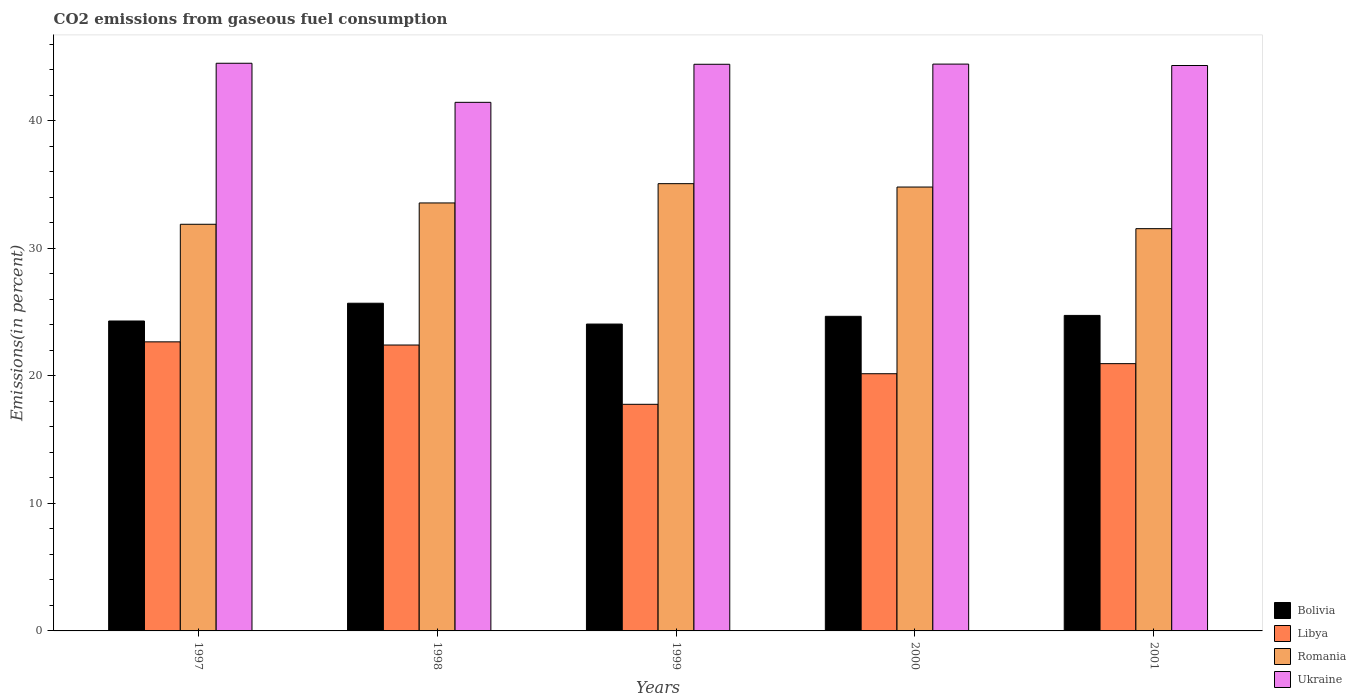How many groups of bars are there?
Make the answer very short. 5. Are the number of bars on each tick of the X-axis equal?
Give a very brief answer. Yes. How many bars are there on the 3rd tick from the left?
Your response must be concise. 4. How many bars are there on the 3rd tick from the right?
Your answer should be very brief. 4. In how many cases, is the number of bars for a given year not equal to the number of legend labels?
Offer a very short reply. 0. What is the total CO2 emitted in Bolivia in 1998?
Keep it short and to the point. 25.7. Across all years, what is the maximum total CO2 emitted in Bolivia?
Offer a very short reply. 25.7. Across all years, what is the minimum total CO2 emitted in Romania?
Your answer should be very brief. 31.55. In which year was the total CO2 emitted in Romania maximum?
Your response must be concise. 1999. In which year was the total CO2 emitted in Libya minimum?
Your answer should be compact. 1999. What is the total total CO2 emitted in Libya in the graph?
Your answer should be compact. 104.02. What is the difference between the total CO2 emitted in Bolivia in 1998 and that in 1999?
Provide a succinct answer. 1.63. What is the difference between the total CO2 emitted in Ukraine in 1998 and the total CO2 emitted in Libya in 1997?
Offer a very short reply. 18.79. What is the average total CO2 emitted in Romania per year?
Your answer should be very brief. 33.38. In the year 2000, what is the difference between the total CO2 emitted in Romania and total CO2 emitted in Ukraine?
Provide a short and direct response. -9.64. In how many years, is the total CO2 emitted in Bolivia greater than 26 %?
Offer a terse response. 0. What is the ratio of the total CO2 emitted in Bolivia in 1999 to that in 2001?
Your answer should be compact. 0.97. Is the total CO2 emitted in Libya in 1998 less than that in 1999?
Give a very brief answer. No. Is the difference between the total CO2 emitted in Romania in 1997 and 1999 greater than the difference between the total CO2 emitted in Ukraine in 1997 and 1999?
Provide a short and direct response. No. What is the difference between the highest and the second highest total CO2 emitted in Bolivia?
Offer a terse response. 0.96. What is the difference between the highest and the lowest total CO2 emitted in Ukraine?
Offer a very short reply. 3.07. Is the sum of the total CO2 emitted in Libya in 1998 and 2001 greater than the maximum total CO2 emitted in Bolivia across all years?
Make the answer very short. Yes. Is it the case that in every year, the sum of the total CO2 emitted in Libya and total CO2 emitted in Romania is greater than the sum of total CO2 emitted in Bolivia and total CO2 emitted in Ukraine?
Make the answer very short. No. What does the 2nd bar from the left in 1998 represents?
Your response must be concise. Libya. What does the 2nd bar from the right in 1998 represents?
Make the answer very short. Romania. Is it the case that in every year, the sum of the total CO2 emitted in Romania and total CO2 emitted in Bolivia is greater than the total CO2 emitted in Libya?
Offer a very short reply. Yes. How many years are there in the graph?
Provide a succinct answer. 5. What is the difference between two consecutive major ticks on the Y-axis?
Offer a terse response. 10. Does the graph contain grids?
Provide a succinct answer. No. Where does the legend appear in the graph?
Offer a very short reply. Bottom right. What is the title of the graph?
Your answer should be compact. CO2 emissions from gaseous fuel consumption. Does "Cayman Islands" appear as one of the legend labels in the graph?
Your answer should be very brief. No. What is the label or title of the X-axis?
Keep it short and to the point. Years. What is the label or title of the Y-axis?
Offer a very short reply. Emissions(in percent). What is the Emissions(in percent) in Bolivia in 1997?
Provide a short and direct response. 24.31. What is the Emissions(in percent) of Libya in 1997?
Your answer should be compact. 22.67. What is the Emissions(in percent) of Romania in 1997?
Your answer should be very brief. 31.9. What is the Emissions(in percent) of Ukraine in 1997?
Your answer should be very brief. 44.53. What is the Emissions(in percent) in Bolivia in 1998?
Keep it short and to the point. 25.7. What is the Emissions(in percent) in Libya in 1998?
Provide a short and direct response. 22.43. What is the Emissions(in percent) of Romania in 1998?
Ensure brevity in your answer.  33.57. What is the Emissions(in percent) of Ukraine in 1998?
Provide a succinct answer. 41.46. What is the Emissions(in percent) in Bolivia in 1999?
Provide a short and direct response. 24.07. What is the Emissions(in percent) in Libya in 1999?
Ensure brevity in your answer.  17.78. What is the Emissions(in percent) in Romania in 1999?
Ensure brevity in your answer.  35.08. What is the Emissions(in percent) of Ukraine in 1999?
Keep it short and to the point. 44.45. What is the Emissions(in percent) of Bolivia in 2000?
Keep it short and to the point. 24.68. What is the Emissions(in percent) of Libya in 2000?
Offer a terse response. 20.17. What is the Emissions(in percent) in Romania in 2000?
Make the answer very short. 34.82. What is the Emissions(in percent) of Ukraine in 2000?
Offer a very short reply. 44.46. What is the Emissions(in percent) in Bolivia in 2001?
Your response must be concise. 24.75. What is the Emissions(in percent) of Libya in 2001?
Your answer should be very brief. 20.97. What is the Emissions(in percent) in Romania in 2001?
Offer a very short reply. 31.55. What is the Emissions(in percent) in Ukraine in 2001?
Ensure brevity in your answer.  44.35. Across all years, what is the maximum Emissions(in percent) of Bolivia?
Give a very brief answer. 25.7. Across all years, what is the maximum Emissions(in percent) in Libya?
Ensure brevity in your answer.  22.67. Across all years, what is the maximum Emissions(in percent) of Romania?
Make the answer very short. 35.08. Across all years, what is the maximum Emissions(in percent) in Ukraine?
Provide a short and direct response. 44.53. Across all years, what is the minimum Emissions(in percent) in Bolivia?
Your answer should be very brief. 24.07. Across all years, what is the minimum Emissions(in percent) of Libya?
Ensure brevity in your answer.  17.78. Across all years, what is the minimum Emissions(in percent) in Romania?
Keep it short and to the point. 31.55. Across all years, what is the minimum Emissions(in percent) in Ukraine?
Offer a very short reply. 41.46. What is the total Emissions(in percent) in Bolivia in the graph?
Your answer should be very brief. 123.51. What is the total Emissions(in percent) of Libya in the graph?
Make the answer very short. 104.02. What is the total Emissions(in percent) in Romania in the graph?
Provide a succinct answer. 166.92. What is the total Emissions(in percent) in Ukraine in the graph?
Keep it short and to the point. 219.25. What is the difference between the Emissions(in percent) of Bolivia in 1997 and that in 1998?
Give a very brief answer. -1.39. What is the difference between the Emissions(in percent) of Libya in 1997 and that in 1998?
Offer a very short reply. 0.25. What is the difference between the Emissions(in percent) in Romania in 1997 and that in 1998?
Offer a terse response. -1.67. What is the difference between the Emissions(in percent) in Ukraine in 1997 and that in 1998?
Offer a terse response. 3.07. What is the difference between the Emissions(in percent) of Bolivia in 1997 and that in 1999?
Ensure brevity in your answer.  0.24. What is the difference between the Emissions(in percent) in Libya in 1997 and that in 1999?
Offer a terse response. 4.9. What is the difference between the Emissions(in percent) of Romania in 1997 and that in 1999?
Offer a very short reply. -3.19. What is the difference between the Emissions(in percent) in Ukraine in 1997 and that in 1999?
Keep it short and to the point. 0.08. What is the difference between the Emissions(in percent) in Bolivia in 1997 and that in 2000?
Your answer should be very brief. -0.37. What is the difference between the Emissions(in percent) of Libya in 1997 and that in 2000?
Offer a very short reply. 2.5. What is the difference between the Emissions(in percent) in Romania in 1997 and that in 2000?
Make the answer very short. -2.92. What is the difference between the Emissions(in percent) in Ukraine in 1997 and that in 2000?
Your answer should be very brief. 0.07. What is the difference between the Emissions(in percent) in Bolivia in 1997 and that in 2001?
Ensure brevity in your answer.  -0.44. What is the difference between the Emissions(in percent) in Libya in 1997 and that in 2001?
Make the answer very short. 1.71. What is the difference between the Emissions(in percent) of Romania in 1997 and that in 2001?
Provide a succinct answer. 0.34. What is the difference between the Emissions(in percent) of Ukraine in 1997 and that in 2001?
Keep it short and to the point. 0.18. What is the difference between the Emissions(in percent) in Bolivia in 1998 and that in 1999?
Provide a short and direct response. 1.63. What is the difference between the Emissions(in percent) in Libya in 1998 and that in 1999?
Keep it short and to the point. 4.65. What is the difference between the Emissions(in percent) in Romania in 1998 and that in 1999?
Make the answer very short. -1.51. What is the difference between the Emissions(in percent) of Ukraine in 1998 and that in 1999?
Offer a very short reply. -2.99. What is the difference between the Emissions(in percent) of Libya in 1998 and that in 2000?
Ensure brevity in your answer.  2.25. What is the difference between the Emissions(in percent) of Romania in 1998 and that in 2000?
Give a very brief answer. -1.25. What is the difference between the Emissions(in percent) in Ukraine in 1998 and that in 2000?
Give a very brief answer. -3. What is the difference between the Emissions(in percent) in Bolivia in 1998 and that in 2001?
Make the answer very short. 0.96. What is the difference between the Emissions(in percent) of Libya in 1998 and that in 2001?
Offer a very short reply. 1.46. What is the difference between the Emissions(in percent) in Romania in 1998 and that in 2001?
Offer a very short reply. 2.02. What is the difference between the Emissions(in percent) in Ukraine in 1998 and that in 2001?
Ensure brevity in your answer.  -2.89. What is the difference between the Emissions(in percent) in Bolivia in 1999 and that in 2000?
Offer a very short reply. -0.61. What is the difference between the Emissions(in percent) in Libya in 1999 and that in 2000?
Your response must be concise. -2.4. What is the difference between the Emissions(in percent) of Romania in 1999 and that in 2000?
Your response must be concise. 0.26. What is the difference between the Emissions(in percent) of Ukraine in 1999 and that in 2000?
Keep it short and to the point. -0.01. What is the difference between the Emissions(in percent) of Bolivia in 1999 and that in 2001?
Offer a terse response. -0.68. What is the difference between the Emissions(in percent) of Libya in 1999 and that in 2001?
Your answer should be very brief. -3.19. What is the difference between the Emissions(in percent) of Romania in 1999 and that in 2001?
Offer a very short reply. 3.53. What is the difference between the Emissions(in percent) of Ukraine in 1999 and that in 2001?
Keep it short and to the point. 0.1. What is the difference between the Emissions(in percent) of Bolivia in 2000 and that in 2001?
Your answer should be compact. -0.07. What is the difference between the Emissions(in percent) of Libya in 2000 and that in 2001?
Your answer should be compact. -0.79. What is the difference between the Emissions(in percent) in Romania in 2000 and that in 2001?
Make the answer very short. 3.27. What is the difference between the Emissions(in percent) in Ukraine in 2000 and that in 2001?
Give a very brief answer. 0.11. What is the difference between the Emissions(in percent) of Bolivia in 1997 and the Emissions(in percent) of Libya in 1998?
Provide a short and direct response. 1.88. What is the difference between the Emissions(in percent) in Bolivia in 1997 and the Emissions(in percent) in Romania in 1998?
Provide a short and direct response. -9.26. What is the difference between the Emissions(in percent) of Bolivia in 1997 and the Emissions(in percent) of Ukraine in 1998?
Offer a very short reply. -17.15. What is the difference between the Emissions(in percent) of Libya in 1997 and the Emissions(in percent) of Romania in 1998?
Ensure brevity in your answer.  -10.9. What is the difference between the Emissions(in percent) of Libya in 1997 and the Emissions(in percent) of Ukraine in 1998?
Make the answer very short. -18.79. What is the difference between the Emissions(in percent) of Romania in 1997 and the Emissions(in percent) of Ukraine in 1998?
Your response must be concise. -9.56. What is the difference between the Emissions(in percent) of Bolivia in 1997 and the Emissions(in percent) of Libya in 1999?
Your response must be concise. 6.53. What is the difference between the Emissions(in percent) of Bolivia in 1997 and the Emissions(in percent) of Romania in 1999?
Offer a very short reply. -10.77. What is the difference between the Emissions(in percent) of Bolivia in 1997 and the Emissions(in percent) of Ukraine in 1999?
Provide a succinct answer. -20.14. What is the difference between the Emissions(in percent) in Libya in 1997 and the Emissions(in percent) in Romania in 1999?
Your response must be concise. -12.41. What is the difference between the Emissions(in percent) of Libya in 1997 and the Emissions(in percent) of Ukraine in 1999?
Offer a very short reply. -21.77. What is the difference between the Emissions(in percent) in Romania in 1997 and the Emissions(in percent) in Ukraine in 1999?
Make the answer very short. -12.55. What is the difference between the Emissions(in percent) in Bolivia in 1997 and the Emissions(in percent) in Libya in 2000?
Provide a short and direct response. 4.14. What is the difference between the Emissions(in percent) in Bolivia in 1997 and the Emissions(in percent) in Romania in 2000?
Make the answer very short. -10.51. What is the difference between the Emissions(in percent) in Bolivia in 1997 and the Emissions(in percent) in Ukraine in 2000?
Make the answer very short. -20.15. What is the difference between the Emissions(in percent) of Libya in 1997 and the Emissions(in percent) of Romania in 2000?
Your answer should be compact. -12.14. What is the difference between the Emissions(in percent) of Libya in 1997 and the Emissions(in percent) of Ukraine in 2000?
Keep it short and to the point. -21.79. What is the difference between the Emissions(in percent) in Romania in 1997 and the Emissions(in percent) in Ukraine in 2000?
Give a very brief answer. -12.56. What is the difference between the Emissions(in percent) of Bolivia in 1997 and the Emissions(in percent) of Libya in 2001?
Keep it short and to the point. 3.34. What is the difference between the Emissions(in percent) in Bolivia in 1997 and the Emissions(in percent) in Romania in 2001?
Your answer should be very brief. -7.24. What is the difference between the Emissions(in percent) in Bolivia in 1997 and the Emissions(in percent) in Ukraine in 2001?
Ensure brevity in your answer.  -20.04. What is the difference between the Emissions(in percent) of Libya in 1997 and the Emissions(in percent) of Romania in 2001?
Give a very brief answer. -8.88. What is the difference between the Emissions(in percent) of Libya in 1997 and the Emissions(in percent) of Ukraine in 2001?
Offer a very short reply. -21.68. What is the difference between the Emissions(in percent) of Romania in 1997 and the Emissions(in percent) of Ukraine in 2001?
Provide a short and direct response. -12.45. What is the difference between the Emissions(in percent) of Bolivia in 1998 and the Emissions(in percent) of Libya in 1999?
Your answer should be very brief. 7.93. What is the difference between the Emissions(in percent) of Bolivia in 1998 and the Emissions(in percent) of Romania in 1999?
Your answer should be compact. -9.38. What is the difference between the Emissions(in percent) in Bolivia in 1998 and the Emissions(in percent) in Ukraine in 1999?
Offer a very short reply. -18.74. What is the difference between the Emissions(in percent) of Libya in 1998 and the Emissions(in percent) of Romania in 1999?
Make the answer very short. -12.66. What is the difference between the Emissions(in percent) of Libya in 1998 and the Emissions(in percent) of Ukraine in 1999?
Ensure brevity in your answer.  -22.02. What is the difference between the Emissions(in percent) in Romania in 1998 and the Emissions(in percent) in Ukraine in 1999?
Your response must be concise. -10.88. What is the difference between the Emissions(in percent) in Bolivia in 1998 and the Emissions(in percent) in Libya in 2000?
Offer a terse response. 5.53. What is the difference between the Emissions(in percent) of Bolivia in 1998 and the Emissions(in percent) of Romania in 2000?
Provide a succinct answer. -9.11. What is the difference between the Emissions(in percent) in Bolivia in 1998 and the Emissions(in percent) in Ukraine in 2000?
Your answer should be compact. -18.76. What is the difference between the Emissions(in percent) of Libya in 1998 and the Emissions(in percent) of Romania in 2000?
Your response must be concise. -12.39. What is the difference between the Emissions(in percent) in Libya in 1998 and the Emissions(in percent) in Ukraine in 2000?
Give a very brief answer. -22.03. What is the difference between the Emissions(in percent) of Romania in 1998 and the Emissions(in percent) of Ukraine in 2000?
Your answer should be compact. -10.89. What is the difference between the Emissions(in percent) of Bolivia in 1998 and the Emissions(in percent) of Libya in 2001?
Your answer should be compact. 4.74. What is the difference between the Emissions(in percent) in Bolivia in 1998 and the Emissions(in percent) in Romania in 2001?
Make the answer very short. -5.85. What is the difference between the Emissions(in percent) in Bolivia in 1998 and the Emissions(in percent) in Ukraine in 2001?
Offer a very short reply. -18.65. What is the difference between the Emissions(in percent) in Libya in 1998 and the Emissions(in percent) in Romania in 2001?
Offer a terse response. -9.13. What is the difference between the Emissions(in percent) of Libya in 1998 and the Emissions(in percent) of Ukraine in 2001?
Offer a terse response. -21.92. What is the difference between the Emissions(in percent) in Romania in 1998 and the Emissions(in percent) in Ukraine in 2001?
Provide a succinct answer. -10.78. What is the difference between the Emissions(in percent) in Bolivia in 1999 and the Emissions(in percent) in Libya in 2000?
Make the answer very short. 3.9. What is the difference between the Emissions(in percent) in Bolivia in 1999 and the Emissions(in percent) in Romania in 2000?
Your answer should be compact. -10.75. What is the difference between the Emissions(in percent) of Bolivia in 1999 and the Emissions(in percent) of Ukraine in 2000?
Your answer should be compact. -20.39. What is the difference between the Emissions(in percent) in Libya in 1999 and the Emissions(in percent) in Romania in 2000?
Make the answer very short. -17.04. What is the difference between the Emissions(in percent) of Libya in 1999 and the Emissions(in percent) of Ukraine in 2000?
Keep it short and to the point. -26.68. What is the difference between the Emissions(in percent) of Romania in 1999 and the Emissions(in percent) of Ukraine in 2000?
Offer a very short reply. -9.38. What is the difference between the Emissions(in percent) in Bolivia in 1999 and the Emissions(in percent) in Libya in 2001?
Make the answer very short. 3.11. What is the difference between the Emissions(in percent) in Bolivia in 1999 and the Emissions(in percent) in Romania in 2001?
Provide a short and direct response. -7.48. What is the difference between the Emissions(in percent) in Bolivia in 1999 and the Emissions(in percent) in Ukraine in 2001?
Ensure brevity in your answer.  -20.28. What is the difference between the Emissions(in percent) in Libya in 1999 and the Emissions(in percent) in Romania in 2001?
Your answer should be very brief. -13.78. What is the difference between the Emissions(in percent) in Libya in 1999 and the Emissions(in percent) in Ukraine in 2001?
Your answer should be very brief. -26.57. What is the difference between the Emissions(in percent) in Romania in 1999 and the Emissions(in percent) in Ukraine in 2001?
Make the answer very short. -9.27. What is the difference between the Emissions(in percent) of Bolivia in 2000 and the Emissions(in percent) of Libya in 2001?
Offer a very short reply. 3.71. What is the difference between the Emissions(in percent) of Bolivia in 2000 and the Emissions(in percent) of Romania in 2001?
Offer a very short reply. -6.88. What is the difference between the Emissions(in percent) of Bolivia in 2000 and the Emissions(in percent) of Ukraine in 2001?
Your answer should be compact. -19.67. What is the difference between the Emissions(in percent) of Libya in 2000 and the Emissions(in percent) of Romania in 2001?
Make the answer very short. -11.38. What is the difference between the Emissions(in percent) of Libya in 2000 and the Emissions(in percent) of Ukraine in 2001?
Give a very brief answer. -24.18. What is the difference between the Emissions(in percent) of Romania in 2000 and the Emissions(in percent) of Ukraine in 2001?
Your answer should be compact. -9.53. What is the average Emissions(in percent) in Bolivia per year?
Your response must be concise. 24.7. What is the average Emissions(in percent) of Libya per year?
Your response must be concise. 20.8. What is the average Emissions(in percent) in Romania per year?
Your answer should be very brief. 33.38. What is the average Emissions(in percent) of Ukraine per year?
Give a very brief answer. 43.85. In the year 1997, what is the difference between the Emissions(in percent) in Bolivia and Emissions(in percent) in Libya?
Your answer should be compact. 1.64. In the year 1997, what is the difference between the Emissions(in percent) of Bolivia and Emissions(in percent) of Romania?
Keep it short and to the point. -7.59. In the year 1997, what is the difference between the Emissions(in percent) in Bolivia and Emissions(in percent) in Ukraine?
Keep it short and to the point. -20.22. In the year 1997, what is the difference between the Emissions(in percent) in Libya and Emissions(in percent) in Romania?
Provide a short and direct response. -9.22. In the year 1997, what is the difference between the Emissions(in percent) of Libya and Emissions(in percent) of Ukraine?
Ensure brevity in your answer.  -21.85. In the year 1997, what is the difference between the Emissions(in percent) of Romania and Emissions(in percent) of Ukraine?
Provide a succinct answer. -12.63. In the year 1998, what is the difference between the Emissions(in percent) of Bolivia and Emissions(in percent) of Libya?
Keep it short and to the point. 3.28. In the year 1998, what is the difference between the Emissions(in percent) in Bolivia and Emissions(in percent) in Romania?
Offer a terse response. -7.87. In the year 1998, what is the difference between the Emissions(in percent) of Bolivia and Emissions(in percent) of Ukraine?
Your response must be concise. -15.76. In the year 1998, what is the difference between the Emissions(in percent) of Libya and Emissions(in percent) of Romania?
Provide a succinct answer. -11.14. In the year 1998, what is the difference between the Emissions(in percent) of Libya and Emissions(in percent) of Ukraine?
Give a very brief answer. -19.04. In the year 1998, what is the difference between the Emissions(in percent) of Romania and Emissions(in percent) of Ukraine?
Make the answer very short. -7.89. In the year 1999, what is the difference between the Emissions(in percent) of Bolivia and Emissions(in percent) of Libya?
Make the answer very short. 6.29. In the year 1999, what is the difference between the Emissions(in percent) in Bolivia and Emissions(in percent) in Romania?
Your answer should be compact. -11.01. In the year 1999, what is the difference between the Emissions(in percent) in Bolivia and Emissions(in percent) in Ukraine?
Give a very brief answer. -20.38. In the year 1999, what is the difference between the Emissions(in percent) of Libya and Emissions(in percent) of Romania?
Keep it short and to the point. -17.31. In the year 1999, what is the difference between the Emissions(in percent) in Libya and Emissions(in percent) in Ukraine?
Give a very brief answer. -26.67. In the year 1999, what is the difference between the Emissions(in percent) in Romania and Emissions(in percent) in Ukraine?
Make the answer very short. -9.36. In the year 2000, what is the difference between the Emissions(in percent) in Bolivia and Emissions(in percent) in Libya?
Ensure brevity in your answer.  4.5. In the year 2000, what is the difference between the Emissions(in percent) of Bolivia and Emissions(in percent) of Romania?
Keep it short and to the point. -10.14. In the year 2000, what is the difference between the Emissions(in percent) in Bolivia and Emissions(in percent) in Ukraine?
Give a very brief answer. -19.78. In the year 2000, what is the difference between the Emissions(in percent) of Libya and Emissions(in percent) of Romania?
Keep it short and to the point. -14.64. In the year 2000, what is the difference between the Emissions(in percent) of Libya and Emissions(in percent) of Ukraine?
Offer a terse response. -24.29. In the year 2000, what is the difference between the Emissions(in percent) of Romania and Emissions(in percent) of Ukraine?
Your answer should be very brief. -9.64. In the year 2001, what is the difference between the Emissions(in percent) of Bolivia and Emissions(in percent) of Libya?
Offer a very short reply. 3.78. In the year 2001, what is the difference between the Emissions(in percent) of Bolivia and Emissions(in percent) of Romania?
Offer a terse response. -6.8. In the year 2001, what is the difference between the Emissions(in percent) in Bolivia and Emissions(in percent) in Ukraine?
Offer a very short reply. -19.6. In the year 2001, what is the difference between the Emissions(in percent) in Libya and Emissions(in percent) in Romania?
Provide a short and direct response. -10.59. In the year 2001, what is the difference between the Emissions(in percent) in Libya and Emissions(in percent) in Ukraine?
Provide a short and direct response. -23.39. In the year 2001, what is the difference between the Emissions(in percent) of Romania and Emissions(in percent) of Ukraine?
Offer a terse response. -12.8. What is the ratio of the Emissions(in percent) in Bolivia in 1997 to that in 1998?
Offer a terse response. 0.95. What is the ratio of the Emissions(in percent) in Libya in 1997 to that in 1998?
Ensure brevity in your answer.  1.01. What is the ratio of the Emissions(in percent) in Romania in 1997 to that in 1998?
Make the answer very short. 0.95. What is the ratio of the Emissions(in percent) of Ukraine in 1997 to that in 1998?
Give a very brief answer. 1.07. What is the ratio of the Emissions(in percent) of Bolivia in 1997 to that in 1999?
Your response must be concise. 1.01. What is the ratio of the Emissions(in percent) of Libya in 1997 to that in 1999?
Keep it short and to the point. 1.28. What is the ratio of the Emissions(in percent) in Romania in 1997 to that in 1999?
Your answer should be compact. 0.91. What is the ratio of the Emissions(in percent) of Bolivia in 1997 to that in 2000?
Offer a very short reply. 0.99. What is the ratio of the Emissions(in percent) of Libya in 1997 to that in 2000?
Keep it short and to the point. 1.12. What is the ratio of the Emissions(in percent) in Romania in 1997 to that in 2000?
Offer a very short reply. 0.92. What is the ratio of the Emissions(in percent) of Ukraine in 1997 to that in 2000?
Ensure brevity in your answer.  1. What is the ratio of the Emissions(in percent) in Bolivia in 1997 to that in 2001?
Ensure brevity in your answer.  0.98. What is the ratio of the Emissions(in percent) of Libya in 1997 to that in 2001?
Provide a short and direct response. 1.08. What is the ratio of the Emissions(in percent) in Romania in 1997 to that in 2001?
Give a very brief answer. 1.01. What is the ratio of the Emissions(in percent) of Ukraine in 1997 to that in 2001?
Provide a succinct answer. 1. What is the ratio of the Emissions(in percent) of Bolivia in 1998 to that in 1999?
Give a very brief answer. 1.07. What is the ratio of the Emissions(in percent) of Libya in 1998 to that in 1999?
Your answer should be very brief. 1.26. What is the ratio of the Emissions(in percent) in Romania in 1998 to that in 1999?
Your answer should be very brief. 0.96. What is the ratio of the Emissions(in percent) of Ukraine in 1998 to that in 1999?
Ensure brevity in your answer.  0.93. What is the ratio of the Emissions(in percent) of Bolivia in 1998 to that in 2000?
Provide a succinct answer. 1.04. What is the ratio of the Emissions(in percent) of Libya in 1998 to that in 2000?
Provide a succinct answer. 1.11. What is the ratio of the Emissions(in percent) in Romania in 1998 to that in 2000?
Offer a terse response. 0.96. What is the ratio of the Emissions(in percent) of Ukraine in 1998 to that in 2000?
Keep it short and to the point. 0.93. What is the ratio of the Emissions(in percent) in Bolivia in 1998 to that in 2001?
Keep it short and to the point. 1.04. What is the ratio of the Emissions(in percent) in Libya in 1998 to that in 2001?
Give a very brief answer. 1.07. What is the ratio of the Emissions(in percent) of Romania in 1998 to that in 2001?
Offer a very short reply. 1.06. What is the ratio of the Emissions(in percent) in Ukraine in 1998 to that in 2001?
Provide a succinct answer. 0.93. What is the ratio of the Emissions(in percent) of Bolivia in 1999 to that in 2000?
Provide a short and direct response. 0.98. What is the ratio of the Emissions(in percent) in Libya in 1999 to that in 2000?
Offer a very short reply. 0.88. What is the ratio of the Emissions(in percent) in Romania in 1999 to that in 2000?
Your answer should be very brief. 1.01. What is the ratio of the Emissions(in percent) of Bolivia in 1999 to that in 2001?
Your answer should be compact. 0.97. What is the ratio of the Emissions(in percent) in Libya in 1999 to that in 2001?
Your answer should be very brief. 0.85. What is the ratio of the Emissions(in percent) in Romania in 1999 to that in 2001?
Keep it short and to the point. 1.11. What is the ratio of the Emissions(in percent) of Bolivia in 2000 to that in 2001?
Provide a short and direct response. 1. What is the ratio of the Emissions(in percent) in Libya in 2000 to that in 2001?
Provide a short and direct response. 0.96. What is the ratio of the Emissions(in percent) of Romania in 2000 to that in 2001?
Ensure brevity in your answer.  1.1. What is the ratio of the Emissions(in percent) in Ukraine in 2000 to that in 2001?
Provide a succinct answer. 1. What is the difference between the highest and the second highest Emissions(in percent) in Bolivia?
Offer a very short reply. 0.96. What is the difference between the highest and the second highest Emissions(in percent) in Libya?
Provide a succinct answer. 0.25. What is the difference between the highest and the second highest Emissions(in percent) of Romania?
Give a very brief answer. 0.26. What is the difference between the highest and the second highest Emissions(in percent) of Ukraine?
Provide a succinct answer. 0.07. What is the difference between the highest and the lowest Emissions(in percent) in Bolivia?
Your answer should be very brief. 1.63. What is the difference between the highest and the lowest Emissions(in percent) in Libya?
Keep it short and to the point. 4.9. What is the difference between the highest and the lowest Emissions(in percent) of Romania?
Provide a short and direct response. 3.53. What is the difference between the highest and the lowest Emissions(in percent) in Ukraine?
Offer a terse response. 3.07. 